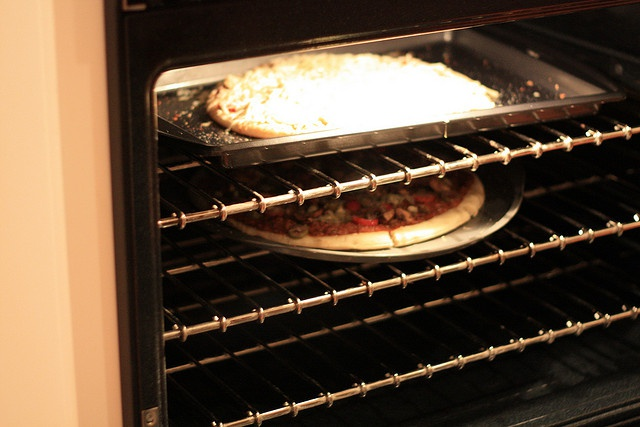Describe the objects in this image and their specific colors. I can see oven in black, tan, maroon, and white tones, pizza in tan, white, khaki, and gold tones, and pizza in tan, black, maroon, and khaki tones in this image. 